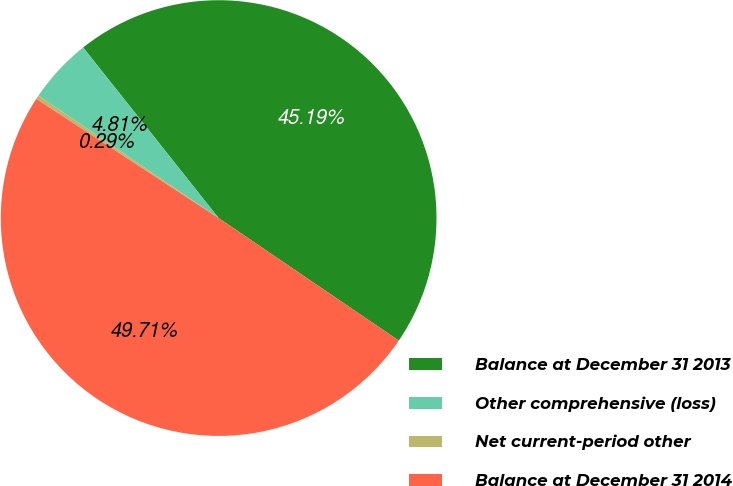Convert chart. <chart><loc_0><loc_0><loc_500><loc_500><pie_chart><fcel>Balance at December 31 2013<fcel>Other comprehensive (loss)<fcel>Net current-period other<fcel>Balance at December 31 2014<nl><fcel>45.19%<fcel>4.81%<fcel>0.29%<fcel>49.71%<nl></chart> 